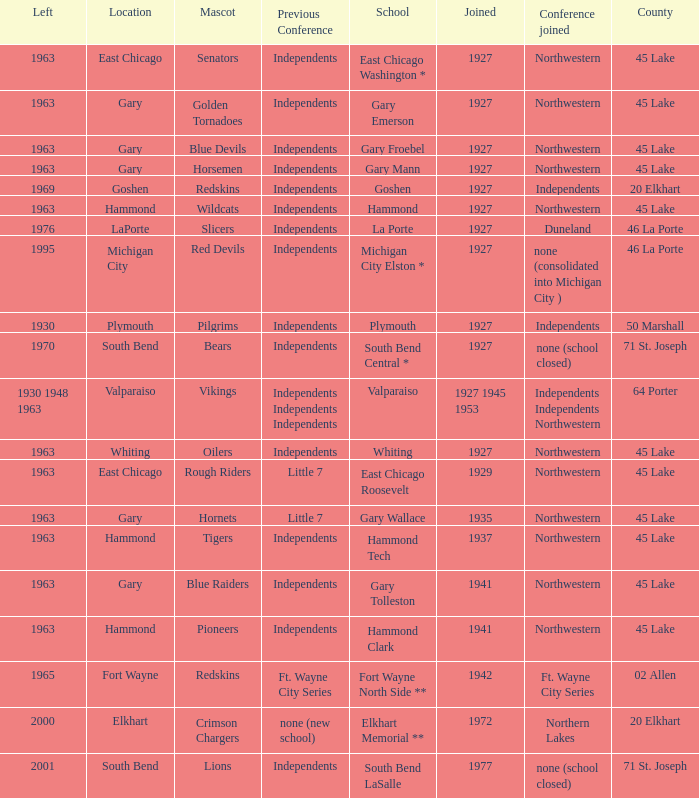When doeas Mascot of blue devils in Gary Froebel School? 1927.0. 